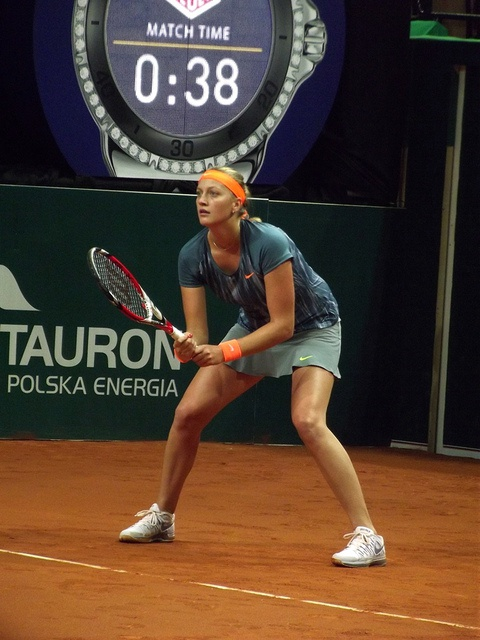Describe the objects in this image and their specific colors. I can see people in black, brown, maroon, and gray tones, clock in black, gray, white, and darkgray tones, and tennis racket in black, gray, maroon, and ivory tones in this image. 